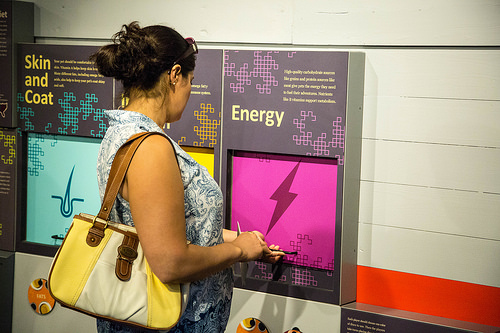<image>
Is the lady in front of the machine? Yes. The lady is positioned in front of the machine, appearing closer to the camera viewpoint. 